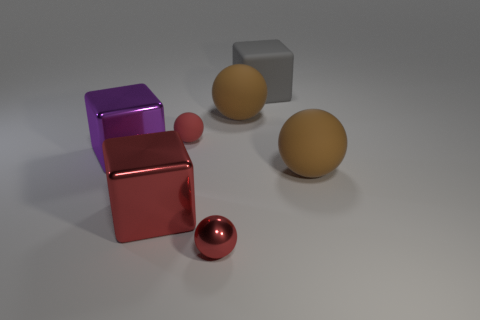How many things are small matte cylinders or large cubes that are on the right side of the big purple shiny block?
Offer a very short reply. 2. How many brown matte objects have the same shape as the small red rubber object?
Make the answer very short. 2. What is the material of the red thing that is the same size as the red matte sphere?
Offer a very short reply. Metal. How big is the gray thing behind the small red thing that is right of the matte object to the left of the red metallic ball?
Provide a short and direct response. Large. There is a tiny matte sphere that is on the left side of the rubber cube; does it have the same color as the big block that is right of the metal sphere?
Offer a very short reply. No. How many purple objects are either large rubber things or large matte blocks?
Your answer should be very brief. 0. How many purple shiny objects are the same size as the gray block?
Keep it short and to the point. 1. Are the brown sphere that is to the left of the large gray thing and the red cube made of the same material?
Provide a short and direct response. No. There is a red ball that is in front of the big purple object; is there a purple metallic cube that is right of it?
Your response must be concise. No. What is the material of the other red thing that is the same shape as the small matte object?
Give a very brief answer. Metal. 